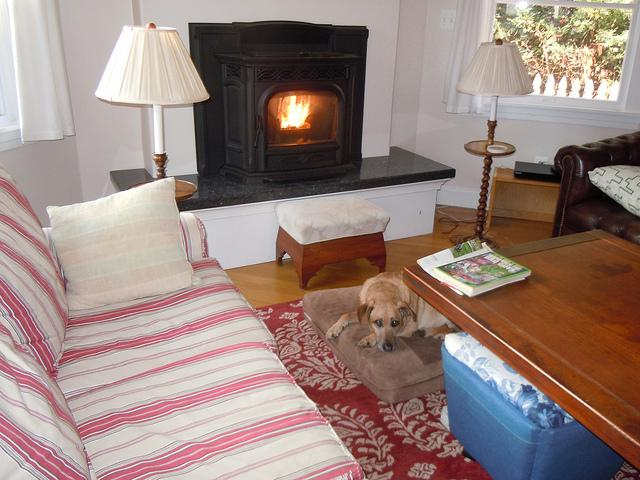What is the dog lying on? dog bed 